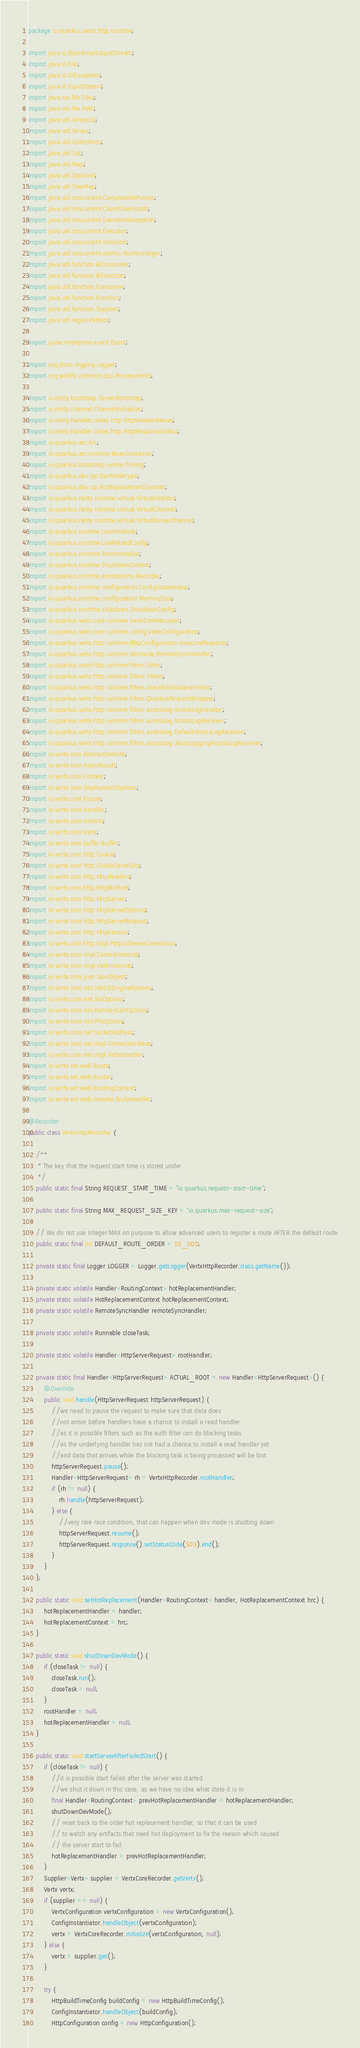Convert code to text. <code><loc_0><loc_0><loc_500><loc_500><_Java_>package io.quarkus.vertx.http.runtime;

import java.io.ByteArrayOutputStream;
import java.io.File;
import java.io.IOException;
import java.io.InputStream;
import java.nio.file.Files;
import java.nio.file.Path;
import java.util.ArrayList;
import java.util.Arrays;
import java.util.Collections;
import java.util.List;
import java.util.Map;
import java.util.Optional;
import java.util.TreeMap;
import java.util.concurrent.CompletableFuture;
import java.util.concurrent.CountDownLatch;
import java.util.concurrent.ExecutionException;
import java.util.concurrent.Executor;
import java.util.concurrent.TimeUnit;
import java.util.concurrent.atomic.AtomicInteger;
import java.util.function.BiConsumer;
import java.util.function.BiFunction;
import java.util.function.Consumer;
import java.util.function.Function;
import java.util.function.Supplier;
import java.util.regex.Pattern;

import javax.enterprise.event.Event;

import org.jboss.logging.Logger;
import org.wildfly.common.cpu.ProcessorInfo;

import io.netty.bootstrap.ServerBootstrap;
import io.netty.channel.ChannelInitializer;
import io.netty.handler.codec.http.HttpHeaderNames;
import io.netty.handler.codec.http.HttpResponseStatus;
import io.quarkus.arc.Arc;
import io.quarkus.arc.runtime.BeanContainer;
import io.quarkus.bootstrap.runner.Timing;
import io.quarkus.dev.spi.DevModeType;
import io.quarkus.dev.spi.HotReplacementContext;
import io.quarkus.netty.runtime.virtual.VirtualAddress;
import io.quarkus.netty.runtime.virtual.VirtualChannel;
import io.quarkus.netty.runtime.virtual.VirtualServerChannel;
import io.quarkus.runtime.LaunchMode;
import io.quarkus.runtime.LiveReloadConfig;
import io.quarkus.runtime.RuntimeValue;
import io.quarkus.runtime.ShutdownContext;
import io.quarkus.runtime.annotations.Recorder;
import io.quarkus.runtime.configuration.ConfigInstantiator;
import io.quarkus.runtime.configuration.MemorySize;
import io.quarkus.runtime.shutdown.ShutdownConfig;
import io.quarkus.vertx.core.runtime.VertxCoreRecorder;
import io.quarkus.vertx.core.runtime.config.VertxConfiguration;
import io.quarkus.vertx.http.runtime.HttpConfiguration.InsecureRequests;
import io.quarkus.vertx.http.runtime.devmode.RemoteSyncHandler;
import io.quarkus.vertx.http.runtime.filters.Filter;
import io.quarkus.vertx.http.runtime.filters.Filters;
import io.quarkus.vertx.http.runtime.filters.GracefulShutdownFilter;
import io.quarkus.vertx.http.runtime.filters.QuarkusRequestWrapper;
import io.quarkus.vertx.http.runtime.filters.accesslog.AccessLogHandler;
import io.quarkus.vertx.http.runtime.filters.accesslog.AccessLogReceiver;
import io.quarkus.vertx.http.runtime.filters.accesslog.DefaultAccessLogReceiver;
import io.quarkus.vertx.http.runtime.filters.accesslog.JBossLoggingAccessLogReceiver;
import io.vertx.core.AbstractVerticle;
import io.vertx.core.AsyncResult;
import io.vertx.core.Context;
import io.vertx.core.DeploymentOptions;
import io.vertx.core.Future;
import io.vertx.core.Handler;
import io.vertx.core.Verticle;
import io.vertx.core.Vertx;
import io.vertx.core.buffer.Buffer;
import io.vertx.core.http.Cookie;
import io.vertx.core.http.CookieSameSite;
import io.vertx.core.http.HttpHeaders;
import io.vertx.core.http.HttpMethod;
import io.vertx.core.http.HttpServer;
import io.vertx.core.http.HttpServerOptions;
import io.vertx.core.http.HttpServerRequest;
import io.vertx.core.http.HttpVersion;
import io.vertx.core.http.impl.Http1xServerConnection;
import io.vertx.core.impl.ContextInternal;
import io.vertx.core.impl.VertxInternal;
import io.vertx.core.json.JsonObject;
import io.vertx.core.net.JdkSSLEngineOptions;
import io.vertx.core.net.JksOptions;
import io.vertx.core.net.PemKeyCertOptions;
import io.vertx.core.net.PfxOptions;
import io.vertx.core.net.SocketAddress;
import io.vertx.core.net.impl.ConnectionBase;
import io.vertx.core.net.impl.VertxHandler;
import io.vertx.ext.web.Route;
import io.vertx.ext.web.Router;
import io.vertx.ext.web.RoutingContext;
import io.vertx.ext.web.handler.BodyHandler;

@Recorder
public class VertxHttpRecorder {

    /**
     * The key that the request start time is stored under
     */
    public static final String REQUEST_START_TIME = "io.quarkus.request-start-time";

    public static final String MAX_REQUEST_SIZE_KEY = "io.quarkus.max-request-size";

    // We do not use Integer.MAX on purpose to allow advanced users to register a route AFTER the default route
    public static final int DEFAULT_ROUTE_ORDER = 10_000;

    private static final Logger LOGGER = Logger.getLogger(VertxHttpRecorder.class.getName());

    private static volatile Handler<RoutingContext> hotReplacementHandler;
    private static volatile HotReplacementContext hotReplacementContext;
    private static volatile RemoteSyncHandler remoteSyncHandler;

    private static volatile Runnable closeTask;

    private static volatile Handler<HttpServerRequest> rootHandler;

    private static final Handler<HttpServerRequest> ACTUAL_ROOT = new Handler<HttpServerRequest>() {
        @Override
        public void handle(HttpServerRequest httpServerRequest) {
            //we need to pause the request to make sure that data does
            //not arrive before handlers have a chance to install a read handler
            //as it is possible filters such as the auth filter can do blocking tasks
            //as the underlying handler has not had a chance to install a read handler yet
            //and data that arrives while the blocking task is being processed will be lost
            httpServerRequest.pause();
            Handler<HttpServerRequest> rh = VertxHttpRecorder.rootHandler;
            if (rh != null) {
                rh.handle(httpServerRequest);
            } else {
                //very rare race condition, that can happen when dev mode is shutting down
                httpServerRequest.resume();
                httpServerRequest.response().setStatusCode(503).end();
            }
        }
    };

    public static void setHotReplacement(Handler<RoutingContext> handler, HotReplacementContext hrc) {
        hotReplacementHandler = handler;
        hotReplacementContext = hrc;
    }

    public static void shutDownDevMode() {
        if (closeTask != null) {
            closeTask.run();
            closeTask = null;
        }
        rootHandler = null;
        hotReplacementHandler = null;
    }

    public static void startServerAfterFailedStart() {
        if (closeTask != null) {
            //it is possible start failed after the server was started
            //we shut it down in this case, as we have no idea what state it is in
            final Handler<RoutingContext> prevHotReplacementHandler = hotReplacementHandler;
            shutDownDevMode();
            // reset back to the older hot replacement handler, so that it can be used
            // to watch any artifacts that need hot deployment to fix the reason which caused
            // the server start to fail
            hotReplacementHandler = prevHotReplacementHandler;
        }
        Supplier<Vertx> supplier = VertxCoreRecorder.getVertx();
        Vertx vertx;
        if (supplier == null) {
            VertxConfiguration vertxConfiguration = new VertxConfiguration();
            ConfigInstantiator.handleObject(vertxConfiguration);
            vertx = VertxCoreRecorder.initialize(vertxConfiguration, null);
        } else {
            vertx = supplier.get();
        }

        try {
            HttpBuildTimeConfig buildConfig = new HttpBuildTimeConfig();
            ConfigInstantiator.handleObject(buildConfig);
            HttpConfiguration config = new HttpConfiguration();</code> 